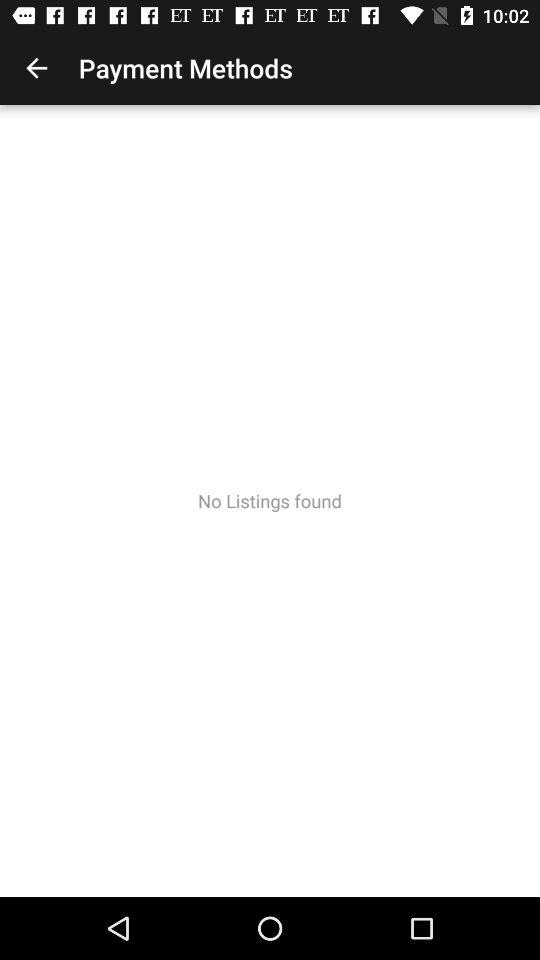Is there any listing found in "Payment Methods"? There is no listing found in "Payment Methods". 